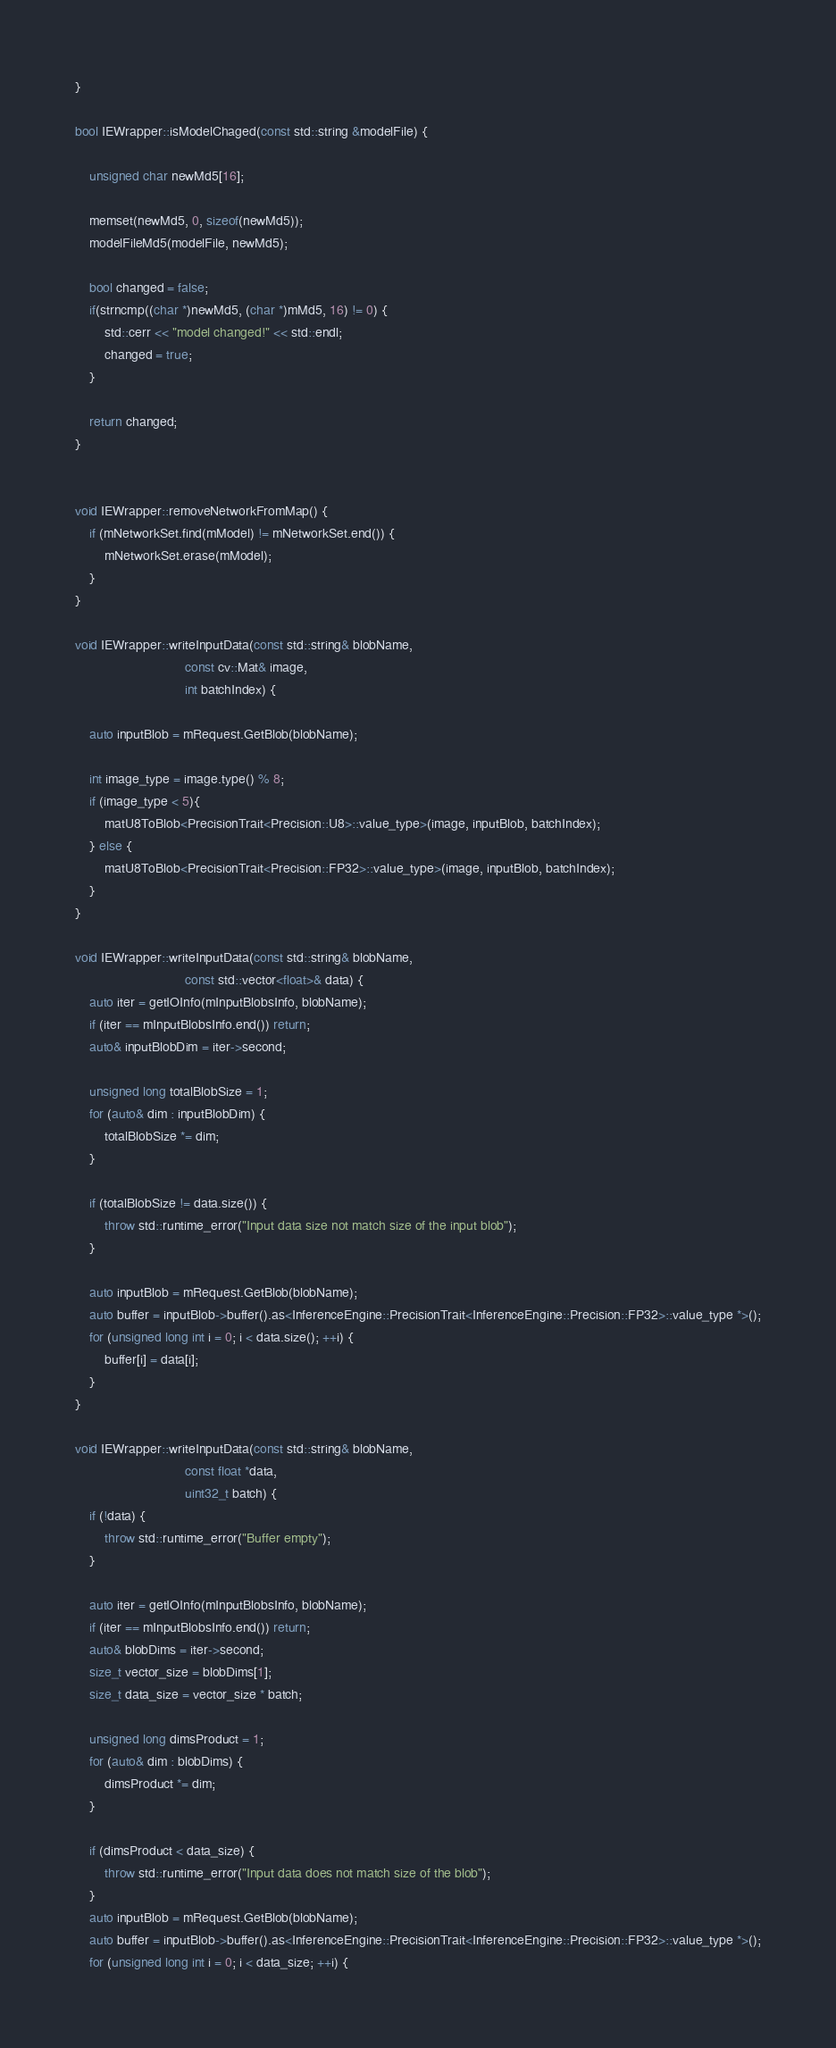<code> <loc_0><loc_0><loc_500><loc_500><_C++_>}

bool IEWrapper::isModelChaged(const std::string &modelFile) {

    unsigned char newMd5[16];

    memset(newMd5, 0, sizeof(newMd5));
    modelFileMd5(modelFile, newMd5);

    bool changed = false;
    if(strncmp((char *)newMd5, (char *)mMd5, 16) != 0) {
        std::cerr << "model changed!" << std::endl;
        changed = true;
    }

    return changed;
}


void IEWrapper::removeNetworkFromMap() {
    if (mNetworkSet.find(mModel) != mNetworkSet.end()) {
        mNetworkSet.erase(mModel);
    }
}

void IEWrapper::writeInputData(const std::string& blobName,
                              const cv::Mat& image,
                              int batchIndex) {

    auto inputBlob = mRequest.GetBlob(blobName);

    int image_type = image.type() % 8;
    if (image_type < 5){
        matU8ToBlob<PrecisionTrait<Precision::U8>::value_type>(image, inputBlob, batchIndex);
    } else {
        matU8ToBlob<PrecisionTrait<Precision::FP32>::value_type>(image, inputBlob, batchIndex);
    }
}

void IEWrapper::writeInputData(const std::string& blobName,
                              const std::vector<float>& data) {
    auto iter = getIOInfo(mInputBlobsInfo, blobName);
    if (iter == mInputBlobsInfo.end()) return;
    auto& inputBlobDim = iter->second;

    unsigned long totalBlobSize = 1;
    for (auto& dim : inputBlobDim) {
        totalBlobSize *= dim;
    }

    if (totalBlobSize != data.size()) {
        throw std::runtime_error("Input data size not match size of the input blob");
    }

    auto inputBlob = mRequest.GetBlob(blobName);
    auto buffer = inputBlob->buffer().as<InferenceEngine::PrecisionTrait<InferenceEngine::Precision::FP32>::value_type *>();
    for (unsigned long int i = 0; i < data.size(); ++i) {
        buffer[i] = data[i];
    }
}

void IEWrapper::writeInputData(const std::string& blobName,
                              const float *data,
                              uint32_t batch) {
    if (!data) {
        throw std::runtime_error("Buffer empty");
    }
 
    auto iter = getIOInfo(mInputBlobsInfo, blobName);
    if (iter == mInputBlobsInfo.end()) return;
    auto& blobDims = iter->second;
    size_t vector_size = blobDims[1];
    size_t data_size = vector_size * batch;

    unsigned long dimsProduct = 1;
    for (auto& dim : blobDims) {
        dimsProduct *= dim;
    }

    if (dimsProduct < data_size) {
        throw std::runtime_error("Input data does not match size of the blob");
    }
    auto inputBlob = mRequest.GetBlob(blobName);
    auto buffer = inputBlob->buffer().as<InferenceEngine::PrecisionTrait<InferenceEngine::Precision::FP32>::value_type *>();
    for (unsigned long int i = 0; i < data_size; ++i) {</code> 